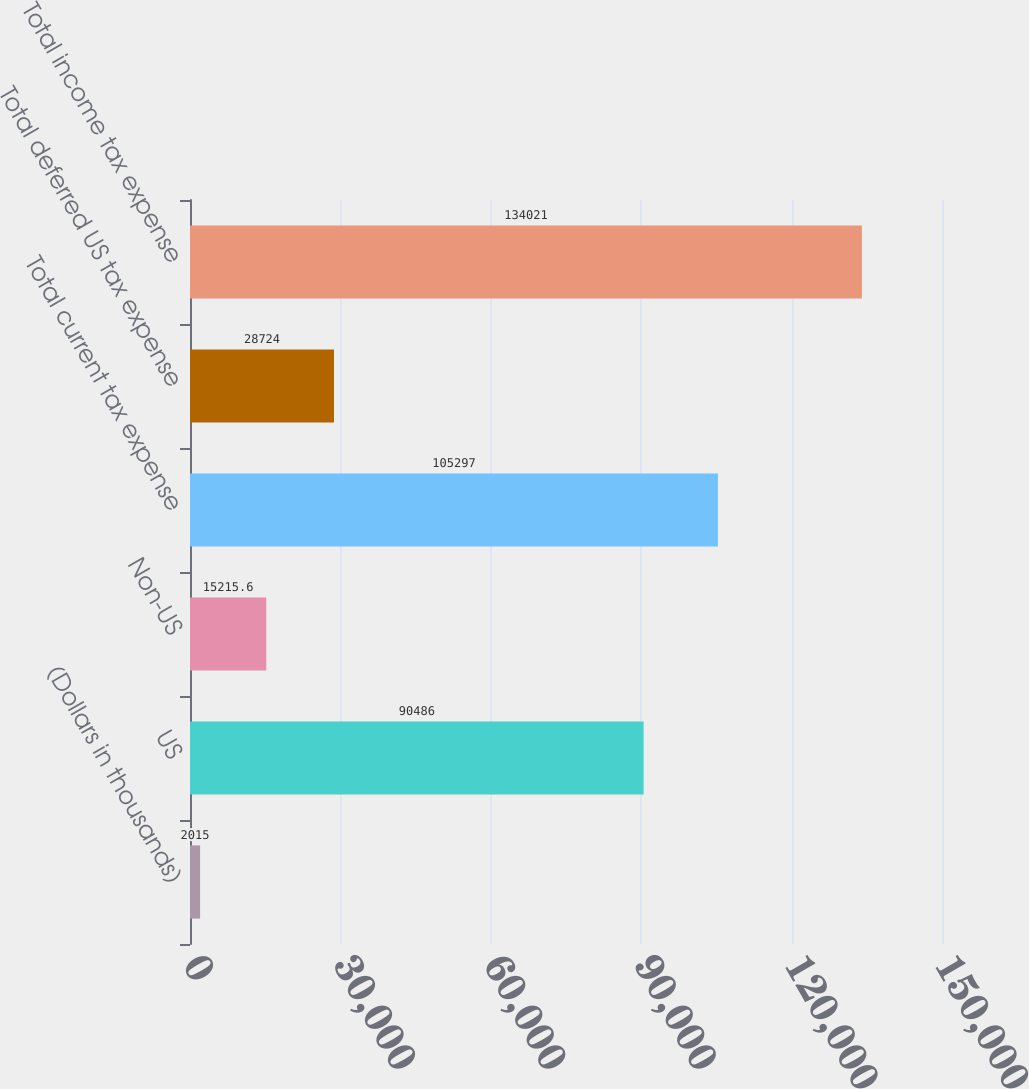Convert chart to OTSL. <chart><loc_0><loc_0><loc_500><loc_500><bar_chart><fcel>(Dollars in thousands)<fcel>US<fcel>Non-US<fcel>Total current tax expense<fcel>Total deferred US tax expense<fcel>Total income tax expense<nl><fcel>2015<fcel>90486<fcel>15215.6<fcel>105297<fcel>28724<fcel>134021<nl></chart> 